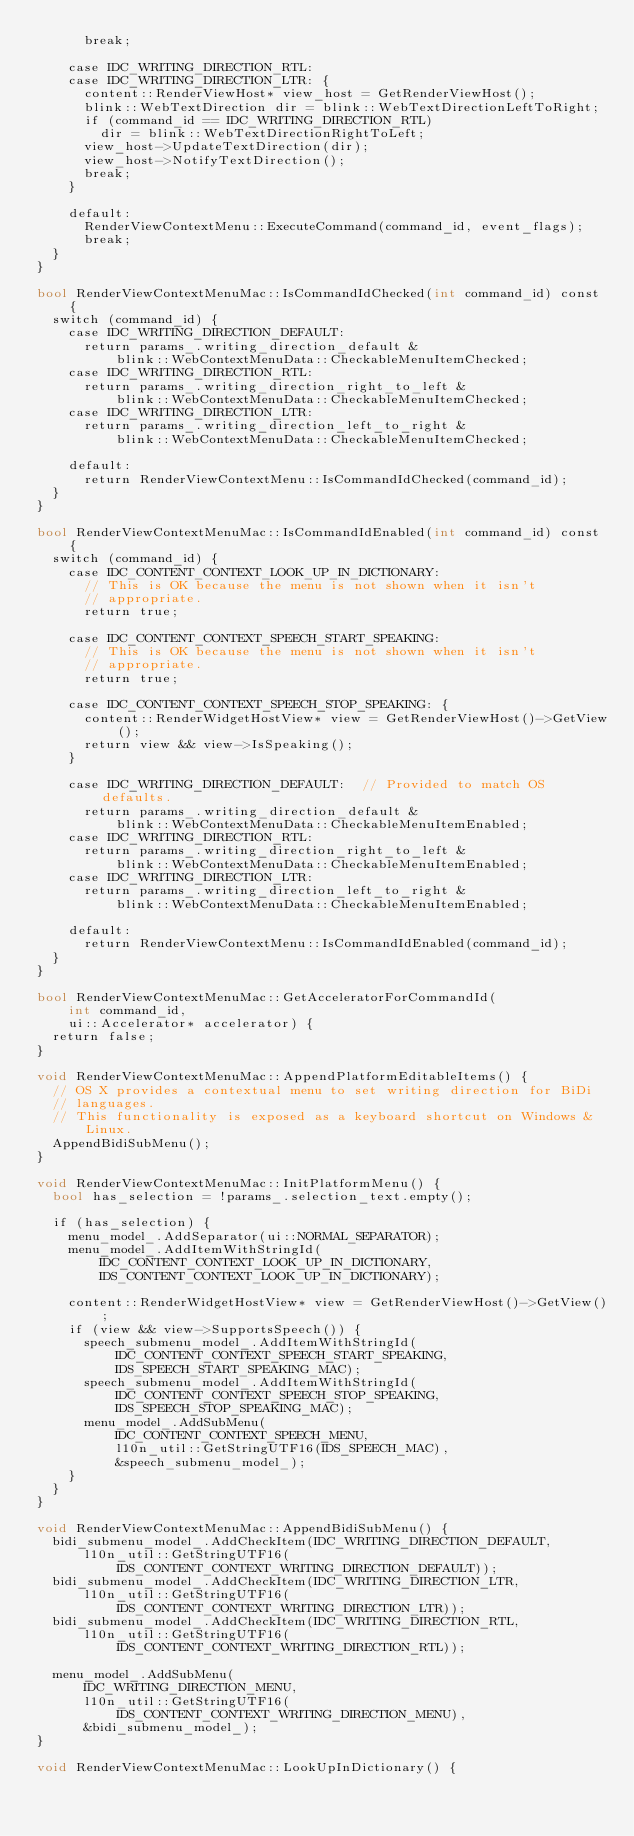<code> <loc_0><loc_0><loc_500><loc_500><_ObjectiveC_>      break;

    case IDC_WRITING_DIRECTION_RTL:
    case IDC_WRITING_DIRECTION_LTR: {
      content::RenderViewHost* view_host = GetRenderViewHost();
      blink::WebTextDirection dir = blink::WebTextDirectionLeftToRight;
      if (command_id == IDC_WRITING_DIRECTION_RTL)
        dir = blink::WebTextDirectionRightToLeft;
      view_host->UpdateTextDirection(dir);
      view_host->NotifyTextDirection();
      break;
    }

    default:
      RenderViewContextMenu::ExecuteCommand(command_id, event_flags);
      break;
  }
}

bool RenderViewContextMenuMac::IsCommandIdChecked(int command_id) const {
  switch (command_id) {
    case IDC_WRITING_DIRECTION_DEFAULT:
      return params_.writing_direction_default &
          blink::WebContextMenuData::CheckableMenuItemChecked;
    case IDC_WRITING_DIRECTION_RTL:
      return params_.writing_direction_right_to_left &
          blink::WebContextMenuData::CheckableMenuItemChecked;
    case IDC_WRITING_DIRECTION_LTR:
      return params_.writing_direction_left_to_right &
          blink::WebContextMenuData::CheckableMenuItemChecked;

    default:
      return RenderViewContextMenu::IsCommandIdChecked(command_id);
  }
}

bool RenderViewContextMenuMac::IsCommandIdEnabled(int command_id) const {
  switch (command_id) {
    case IDC_CONTENT_CONTEXT_LOOK_UP_IN_DICTIONARY:
      // This is OK because the menu is not shown when it isn't
      // appropriate.
      return true;

    case IDC_CONTENT_CONTEXT_SPEECH_START_SPEAKING:
      // This is OK because the menu is not shown when it isn't
      // appropriate.
      return true;

    case IDC_CONTENT_CONTEXT_SPEECH_STOP_SPEAKING: {
      content::RenderWidgetHostView* view = GetRenderViewHost()->GetView();
      return view && view->IsSpeaking();
    }

    case IDC_WRITING_DIRECTION_DEFAULT:  // Provided to match OS defaults.
      return params_.writing_direction_default &
          blink::WebContextMenuData::CheckableMenuItemEnabled;
    case IDC_WRITING_DIRECTION_RTL:
      return params_.writing_direction_right_to_left &
          blink::WebContextMenuData::CheckableMenuItemEnabled;
    case IDC_WRITING_DIRECTION_LTR:
      return params_.writing_direction_left_to_right &
          blink::WebContextMenuData::CheckableMenuItemEnabled;

    default:
      return RenderViewContextMenu::IsCommandIdEnabled(command_id);
  }
}

bool RenderViewContextMenuMac::GetAcceleratorForCommandId(
    int command_id,
    ui::Accelerator* accelerator) {
  return false;
}

void RenderViewContextMenuMac::AppendPlatformEditableItems() {
  // OS X provides a contextual menu to set writing direction for BiDi
  // languages.
  // This functionality is exposed as a keyboard shortcut on Windows & Linux.
  AppendBidiSubMenu();
}

void RenderViewContextMenuMac::InitPlatformMenu() {
  bool has_selection = !params_.selection_text.empty();

  if (has_selection) {
    menu_model_.AddSeparator(ui::NORMAL_SEPARATOR);
    menu_model_.AddItemWithStringId(
        IDC_CONTENT_CONTEXT_LOOK_UP_IN_DICTIONARY,
        IDS_CONTENT_CONTEXT_LOOK_UP_IN_DICTIONARY);

    content::RenderWidgetHostView* view = GetRenderViewHost()->GetView();
    if (view && view->SupportsSpeech()) {
      speech_submenu_model_.AddItemWithStringId(
          IDC_CONTENT_CONTEXT_SPEECH_START_SPEAKING,
          IDS_SPEECH_START_SPEAKING_MAC);
      speech_submenu_model_.AddItemWithStringId(
          IDC_CONTENT_CONTEXT_SPEECH_STOP_SPEAKING,
          IDS_SPEECH_STOP_SPEAKING_MAC);
      menu_model_.AddSubMenu(
          IDC_CONTENT_CONTEXT_SPEECH_MENU,
          l10n_util::GetStringUTF16(IDS_SPEECH_MAC),
          &speech_submenu_model_);
    }
  }
}

void RenderViewContextMenuMac::AppendBidiSubMenu() {
  bidi_submenu_model_.AddCheckItem(IDC_WRITING_DIRECTION_DEFAULT,
      l10n_util::GetStringUTF16(IDS_CONTENT_CONTEXT_WRITING_DIRECTION_DEFAULT));
  bidi_submenu_model_.AddCheckItem(IDC_WRITING_DIRECTION_LTR,
      l10n_util::GetStringUTF16(IDS_CONTENT_CONTEXT_WRITING_DIRECTION_LTR));
  bidi_submenu_model_.AddCheckItem(IDC_WRITING_DIRECTION_RTL,
      l10n_util::GetStringUTF16(IDS_CONTENT_CONTEXT_WRITING_DIRECTION_RTL));

  menu_model_.AddSubMenu(
      IDC_WRITING_DIRECTION_MENU,
      l10n_util::GetStringUTF16(IDS_CONTENT_CONTEXT_WRITING_DIRECTION_MENU),
      &bidi_submenu_model_);
}

void RenderViewContextMenuMac::LookUpInDictionary() {</code> 